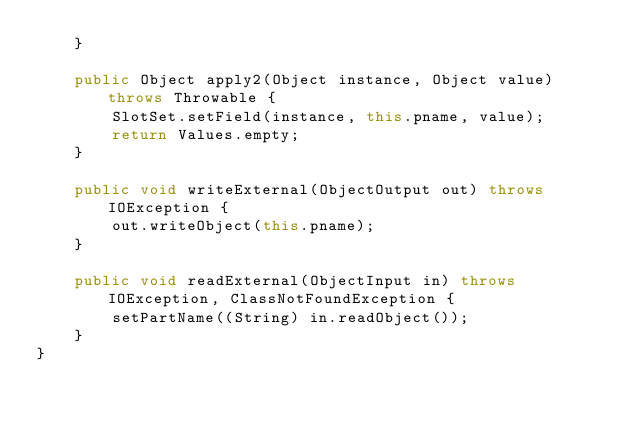<code> <loc_0><loc_0><loc_500><loc_500><_Java_>    }

    public Object apply2(Object instance, Object value) throws Throwable {
        SlotSet.setField(instance, this.pname, value);
        return Values.empty;
    }

    public void writeExternal(ObjectOutput out) throws IOException {
        out.writeObject(this.pname);
    }

    public void readExternal(ObjectInput in) throws IOException, ClassNotFoundException {
        setPartName((String) in.readObject());
    }
}
</code> 